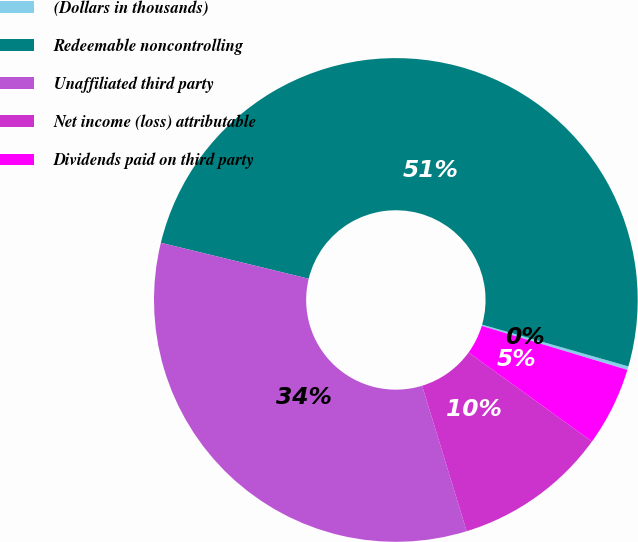Convert chart to OTSL. <chart><loc_0><loc_0><loc_500><loc_500><pie_chart><fcel>(Dollars in thousands)<fcel>Redeemable noncontrolling<fcel>Unaffiliated third party<fcel>Net income (loss) attributable<fcel>Dividends paid on third party<nl><fcel>0.24%<fcel>50.63%<fcel>33.53%<fcel>10.32%<fcel>5.28%<nl></chart> 